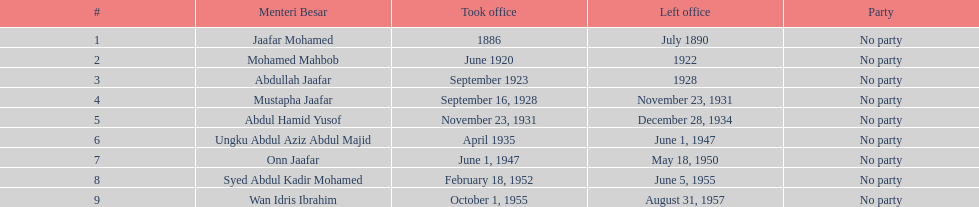Identify an individual who did not hold office for over four years. Mohamed Mahbob. Can you give me this table as a dict? {'header': ['#', 'Menteri Besar', 'Took office', 'Left office', 'Party'], 'rows': [['1', 'Jaafar Mohamed', '1886', 'July 1890', 'No party'], ['2', 'Mohamed Mahbob', 'June 1920', '1922', 'No party'], ['3', 'Abdullah Jaafar', 'September 1923', '1928', 'No party'], ['4', 'Mustapha Jaafar', 'September 16, 1928', 'November 23, 1931', 'No party'], ['5', 'Abdul Hamid Yusof', 'November 23, 1931', 'December 28, 1934', 'No party'], ['6', 'Ungku Abdul Aziz Abdul Majid', 'April 1935', 'June 1, 1947', 'No party'], ['7', 'Onn Jaafar', 'June 1, 1947', 'May 18, 1950', 'No party'], ['8', 'Syed Abdul Kadir Mohamed', 'February 18, 1952', 'June 5, 1955', 'No party'], ['9', 'Wan Idris Ibrahim', 'October 1, 1955', 'August 31, 1957', 'No party']]} 